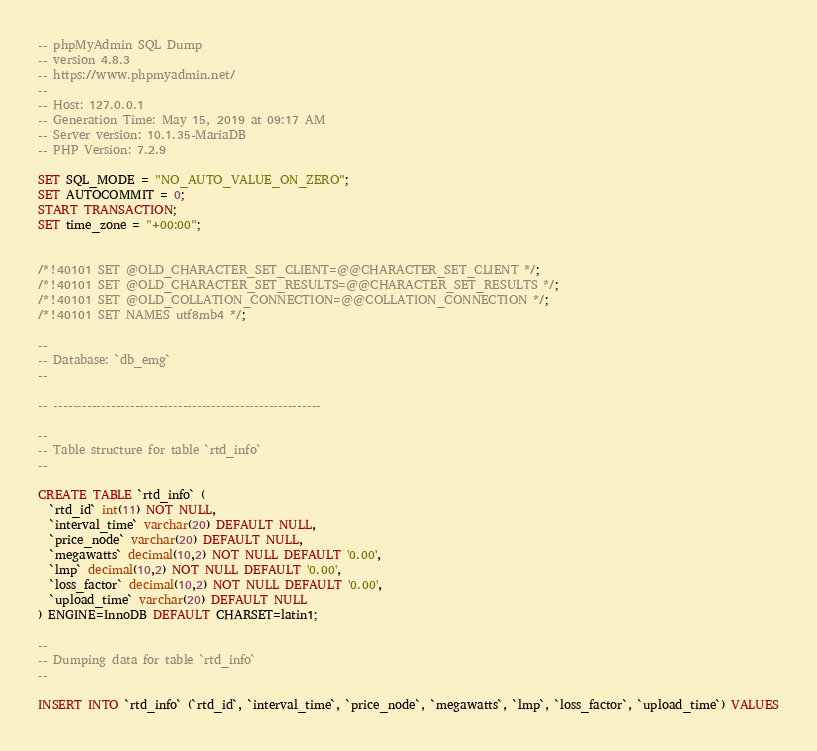Convert code to text. <code><loc_0><loc_0><loc_500><loc_500><_SQL_>-- phpMyAdmin SQL Dump
-- version 4.8.3
-- https://www.phpmyadmin.net/
--
-- Host: 127.0.0.1
-- Generation Time: May 15, 2019 at 09:17 AM
-- Server version: 10.1.35-MariaDB
-- PHP Version: 7.2.9

SET SQL_MODE = "NO_AUTO_VALUE_ON_ZERO";
SET AUTOCOMMIT = 0;
START TRANSACTION;
SET time_zone = "+00:00";


/*!40101 SET @OLD_CHARACTER_SET_CLIENT=@@CHARACTER_SET_CLIENT */;
/*!40101 SET @OLD_CHARACTER_SET_RESULTS=@@CHARACTER_SET_RESULTS */;
/*!40101 SET @OLD_COLLATION_CONNECTION=@@COLLATION_CONNECTION */;
/*!40101 SET NAMES utf8mb4 */;

--
-- Database: `db_emg`
--

-- --------------------------------------------------------

--
-- Table structure for table `rtd_info`
--

CREATE TABLE `rtd_info` (
  `rtd_id` int(11) NOT NULL,
  `interval_time` varchar(20) DEFAULT NULL,
  `price_node` varchar(20) DEFAULT NULL,
  `megawatts` decimal(10,2) NOT NULL DEFAULT '0.00',
  `lmp` decimal(10,2) NOT NULL DEFAULT '0.00',
  `loss_factor` decimal(10,2) NOT NULL DEFAULT '0.00',
  `upload_time` varchar(20) DEFAULT NULL
) ENGINE=InnoDB DEFAULT CHARSET=latin1;

--
-- Dumping data for table `rtd_info`
--

INSERT INTO `rtd_info` (`rtd_id`, `interval_time`, `price_node`, `megawatts`, `lmp`, `loss_factor`, `upload_time`) VALUES</code> 